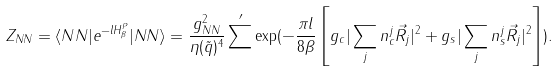Convert formula to latex. <formula><loc_0><loc_0><loc_500><loc_500>Z _ { N N } = \langle N N | e ^ { - l H _ { \beta } ^ { P } } | N N \rangle = \frac { g _ { N N } ^ { 2 } } { \eta ( \tilde { q } ) ^ { 4 } } \sum ^ { \prime } \exp ( - \frac { \pi l } { 8 \beta } \left [ g _ { c } | \sum _ { j } n _ { c } ^ { j } \vec { R } _ { j } | ^ { 2 } + g _ { s } | \sum _ { j } n _ { s } ^ { j } \vec { R } _ { j } | ^ { 2 } \right ] ) .</formula> 